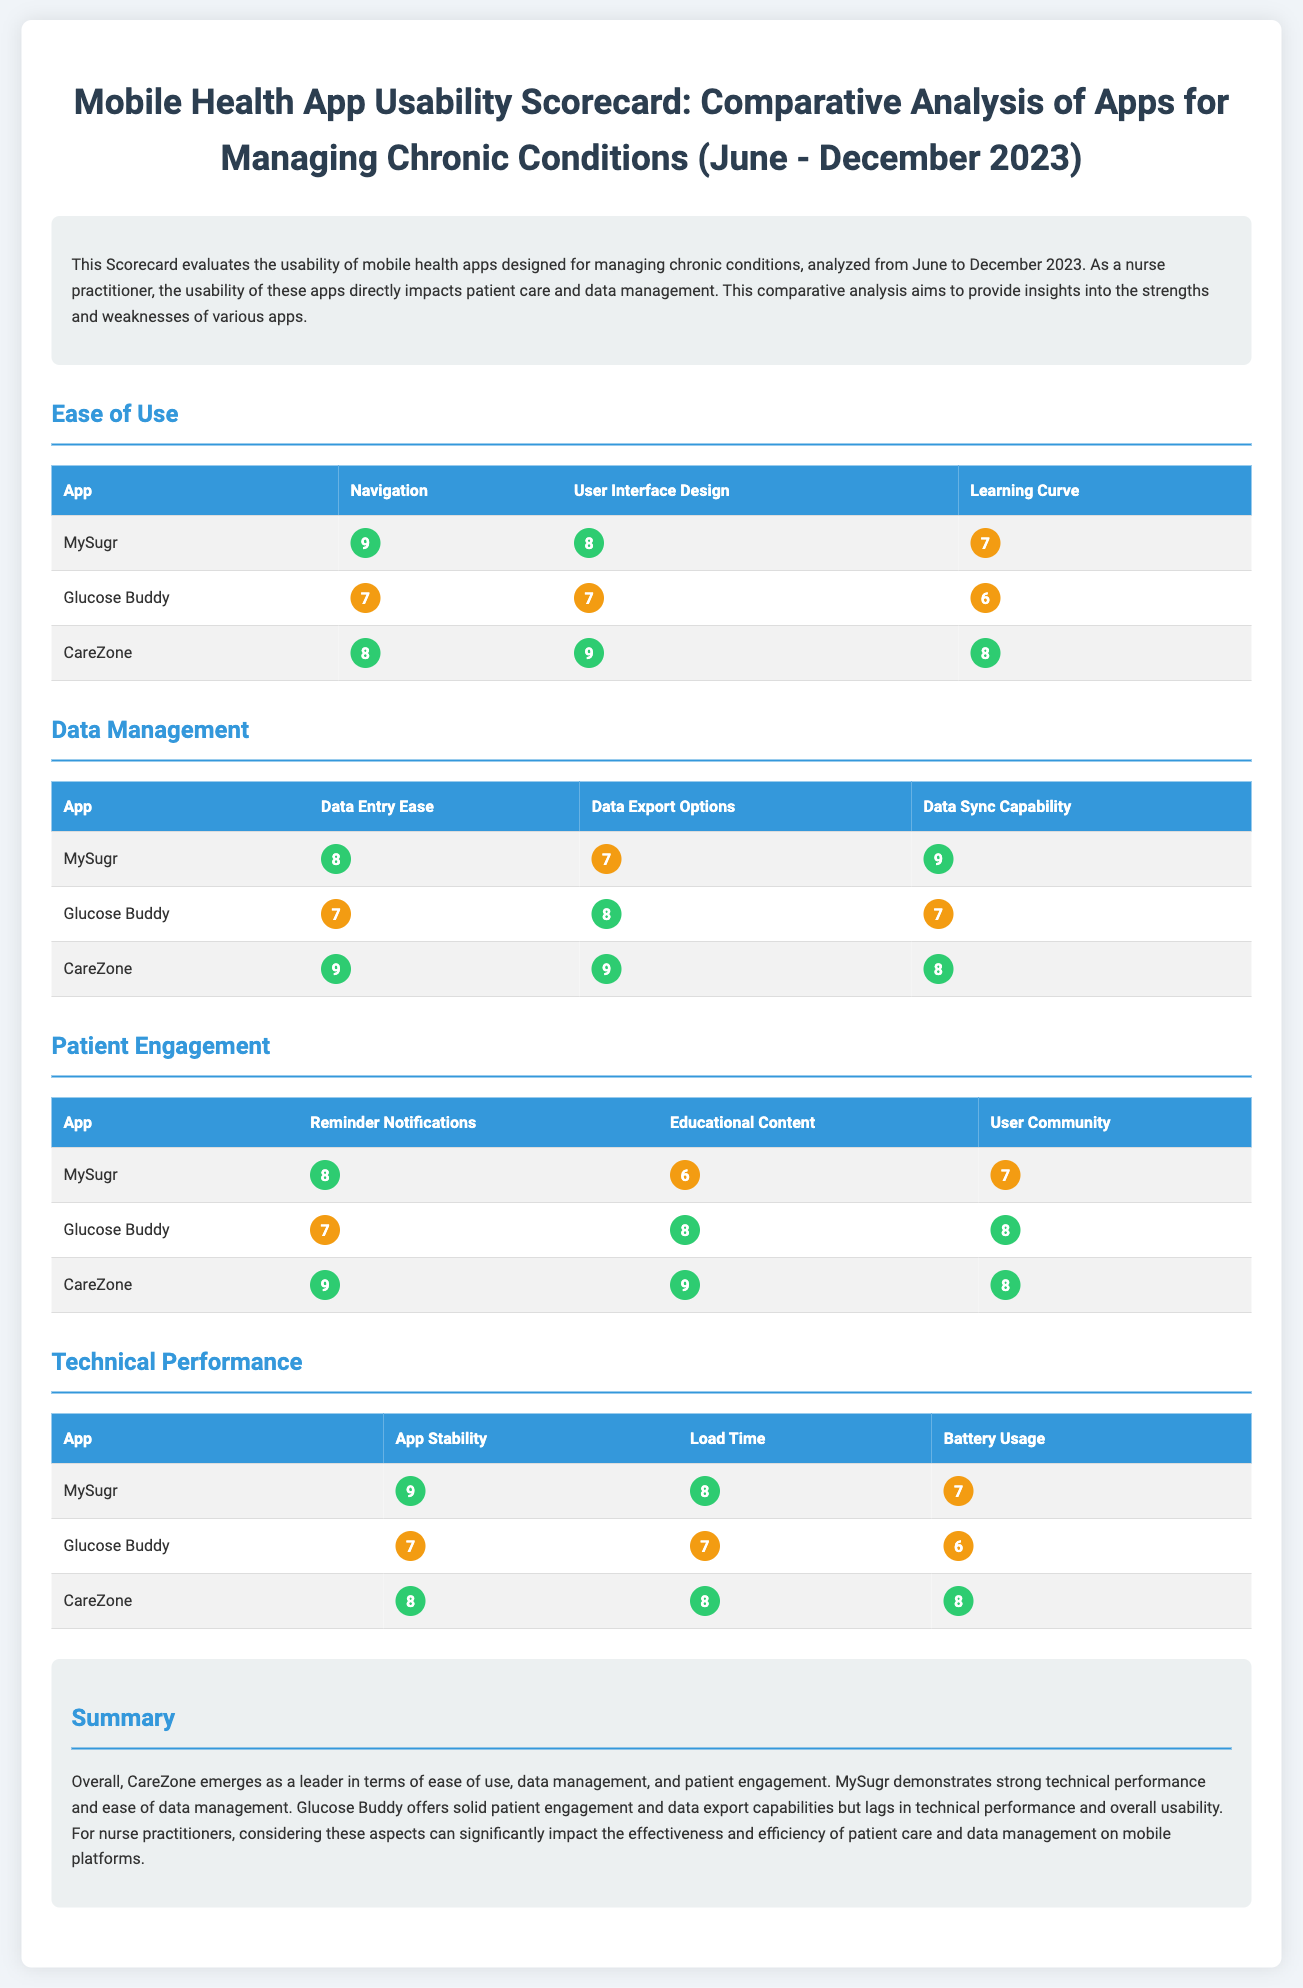what is the highest rating for navigation in the Ease of Use category? The highest rating for navigation is found in the Ease of Use category and is given to the app MySugr with a score of 9.
Answer: 9 which app received the highest rating for Data Sync Capability? The app that received the highest rating for Data Sync Capability is CareZone, rated 8.
Answer: CareZone what rating did Glucose Buddy receive for Educational Content? The rating Glucose Buddy received for Educational Content is high at 8.
Answer: 8 which app demonstrates the best stability as per the Technical Performance category? The app that demonstrates the best stability according to the Technical Performance category is MySugr, rated 9.
Answer: MySugr how many criteria were evaluated in the Patient Engagement category? The criteria evaluated in the Patient Engagement category include Reminder Notifications, Educational Content, and User Community, totaling three criteria.
Answer: three what is the overall conclusion about CareZone in the summary? The overall conclusion about CareZone in the summary indicates it emerges as a leader in terms of ease of use, data management, and patient engagement.
Answer: leader which app has a medium rating for Learning Curve? The app with a medium rating for Learning Curve is Glucose Buddy, rated 6.
Answer: Glucose Buddy what is the rating for Load Time of the app MySugr? The rating for Load Time of the app MySugr is high at 8.
Answer: 8 